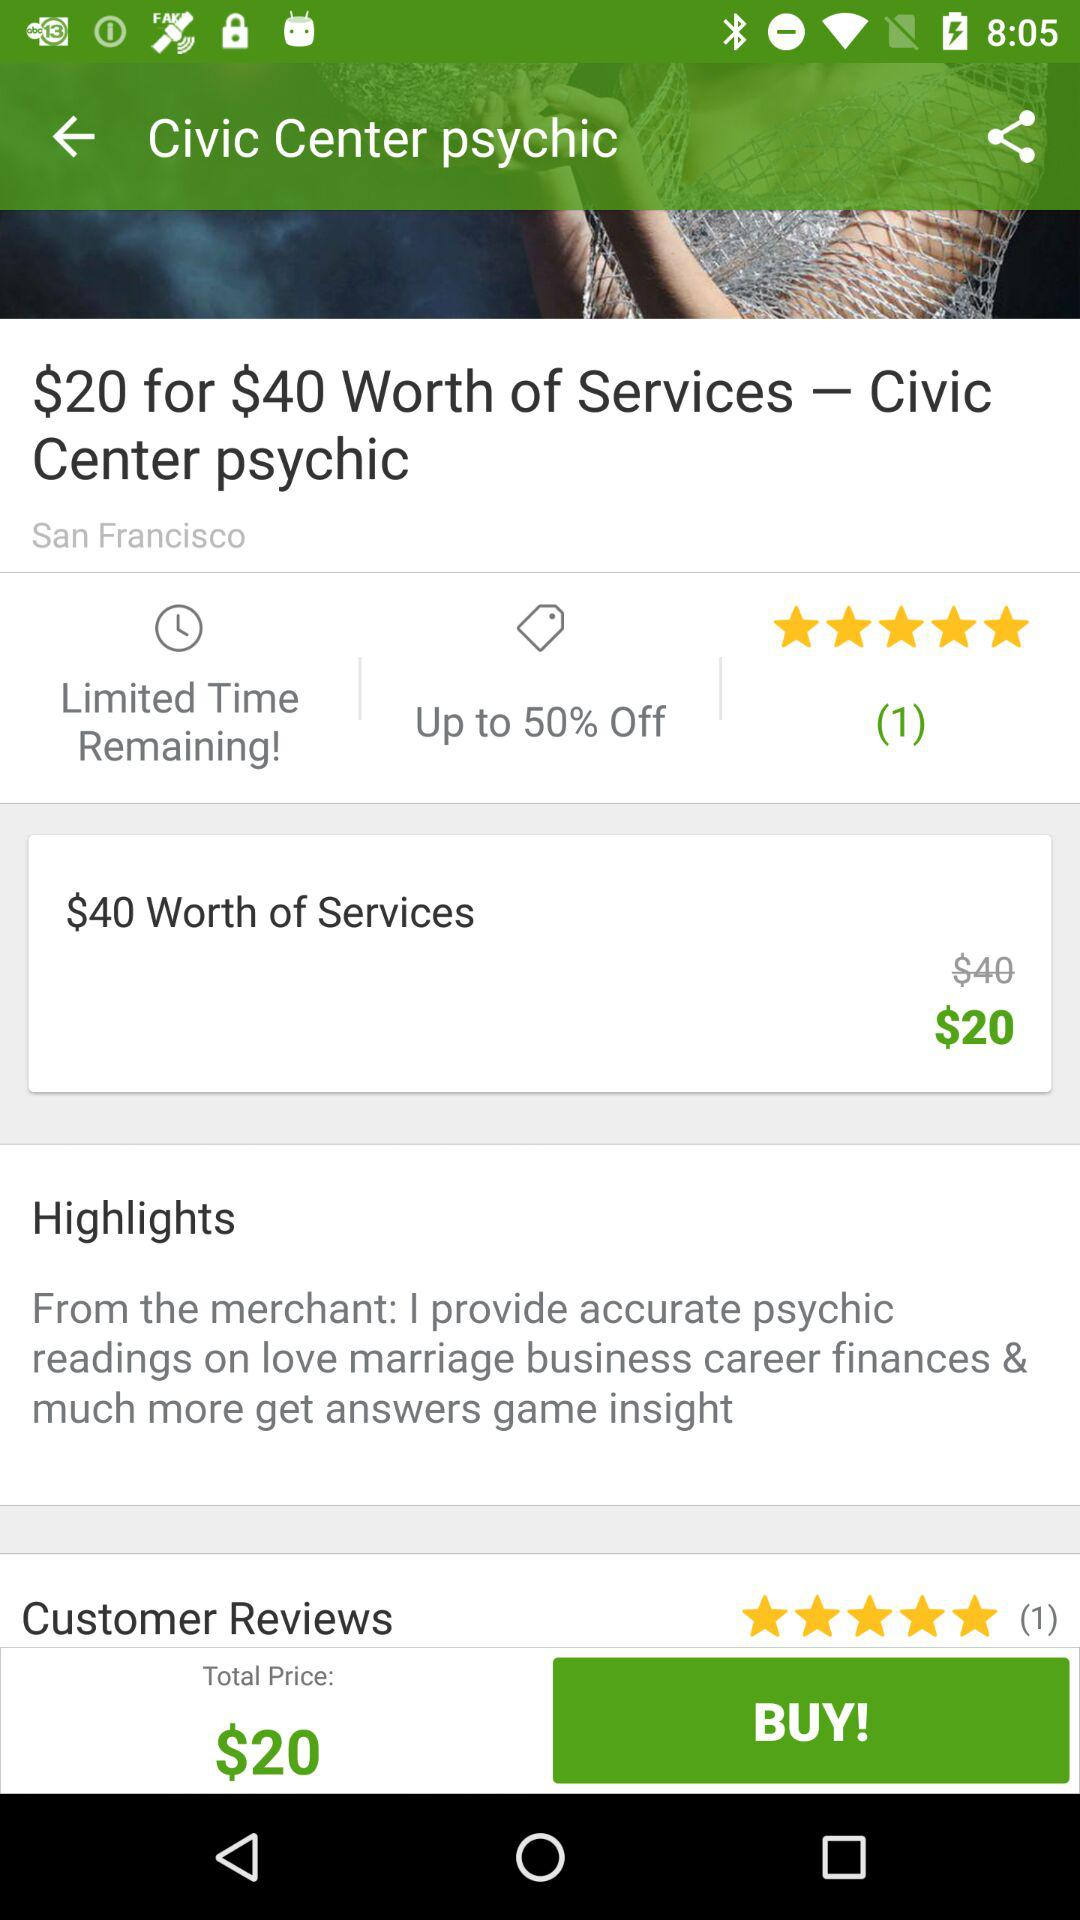What is the remaining time? The remaining time is "Limited". 